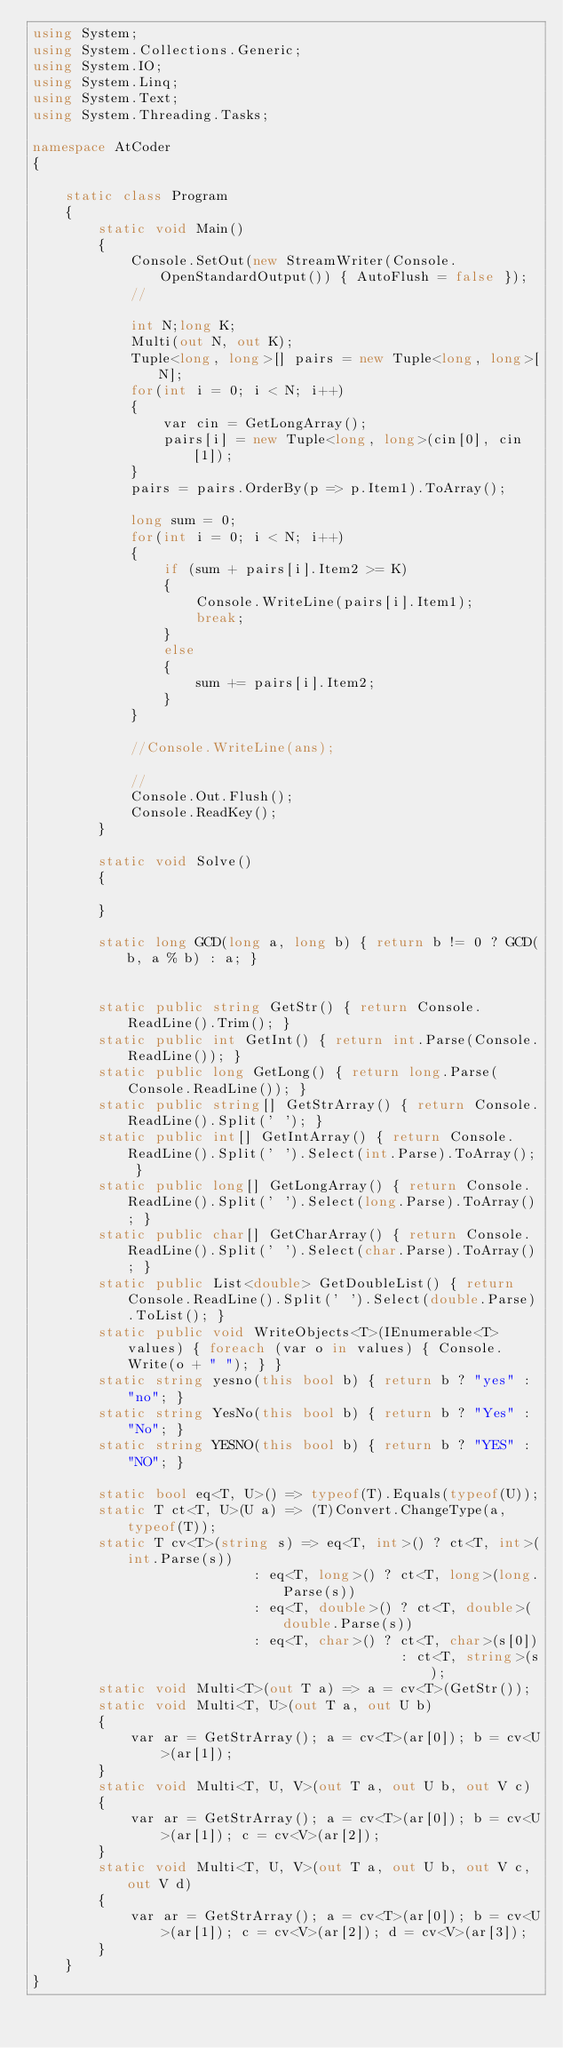<code> <loc_0><loc_0><loc_500><loc_500><_C#_>using System;
using System.Collections.Generic;
using System.IO;
using System.Linq;
using System.Text;
using System.Threading.Tasks;

namespace AtCoder
{

    static class Program
    {
        static void Main()
        {
            Console.SetOut(new StreamWriter(Console.OpenStandardOutput()) { AutoFlush = false });
            //

            int N;long K;
            Multi(out N, out K);
            Tuple<long, long>[] pairs = new Tuple<long, long>[N];
            for(int i = 0; i < N; i++)
            {
                var cin = GetLongArray();
                pairs[i] = new Tuple<long, long>(cin[0], cin[1]);
            }
            pairs = pairs.OrderBy(p => p.Item1).ToArray();

            long sum = 0;
            for(int i = 0; i < N; i++)
            {
                if (sum + pairs[i].Item2 >= K)
                {
                    Console.WriteLine(pairs[i].Item1);
                    break;
                }
                else
                {
                    sum += pairs[i].Item2;
                }
            }

            //Console.WriteLine(ans);

            //
            Console.Out.Flush();
            Console.ReadKey();
        }

        static void Solve()
        {

        }

        static long GCD(long a, long b) { return b != 0 ? GCD(b, a % b) : a; }


        static public string GetStr() { return Console.ReadLine().Trim(); }
        static public int GetInt() { return int.Parse(Console.ReadLine()); }
        static public long GetLong() { return long.Parse(Console.ReadLine()); }
        static public string[] GetStrArray() { return Console.ReadLine().Split(' '); }
        static public int[] GetIntArray() { return Console.ReadLine().Split(' ').Select(int.Parse).ToArray(); }
        static public long[] GetLongArray() { return Console.ReadLine().Split(' ').Select(long.Parse).ToArray(); }
        static public char[] GetCharArray() { return Console.ReadLine().Split(' ').Select(char.Parse).ToArray(); }
        static public List<double> GetDoubleList() { return Console.ReadLine().Split(' ').Select(double.Parse).ToList(); }
        static public void WriteObjects<T>(IEnumerable<T> values) { foreach (var o in values) { Console.Write(o + " "); } }
        static string yesno(this bool b) { return b ? "yes" : "no"; }
        static string YesNo(this bool b) { return b ? "Yes" : "No"; }
        static string YESNO(this bool b) { return b ? "YES" : "NO"; }

        static bool eq<T, U>() => typeof(T).Equals(typeof(U));
        static T ct<T, U>(U a) => (T)Convert.ChangeType(a, typeof(T));
        static T cv<T>(string s) => eq<T, int>() ? ct<T, int>(int.Parse(s))
                           : eq<T, long>() ? ct<T, long>(long.Parse(s))
                           : eq<T, double>() ? ct<T, double>(double.Parse(s))
                           : eq<T, char>() ? ct<T, char>(s[0])
                                             : ct<T, string>(s);
        static void Multi<T>(out T a) => a = cv<T>(GetStr());
        static void Multi<T, U>(out T a, out U b)
        {
            var ar = GetStrArray(); a = cv<T>(ar[0]); b = cv<U>(ar[1]);
        }
        static void Multi<T, U, V>(out T a, out U b, out V c)
        {
            var ar = GetStrArray(); a = cv<T>(ar[0]); b = cv<U>(ar[1]); c = cv<V>(ar[2]);
        }
        static void Multi<T, U, V>(out T a, out U b, out V c, out V d)
        {
            var ar = GetStrArray(); a = cv<T>(ar[0]); b = cv<U>(ar[1]); c = cv<V>(ar[2]); d = cv<V>(ar[3]);
        }
    }
}</code> 